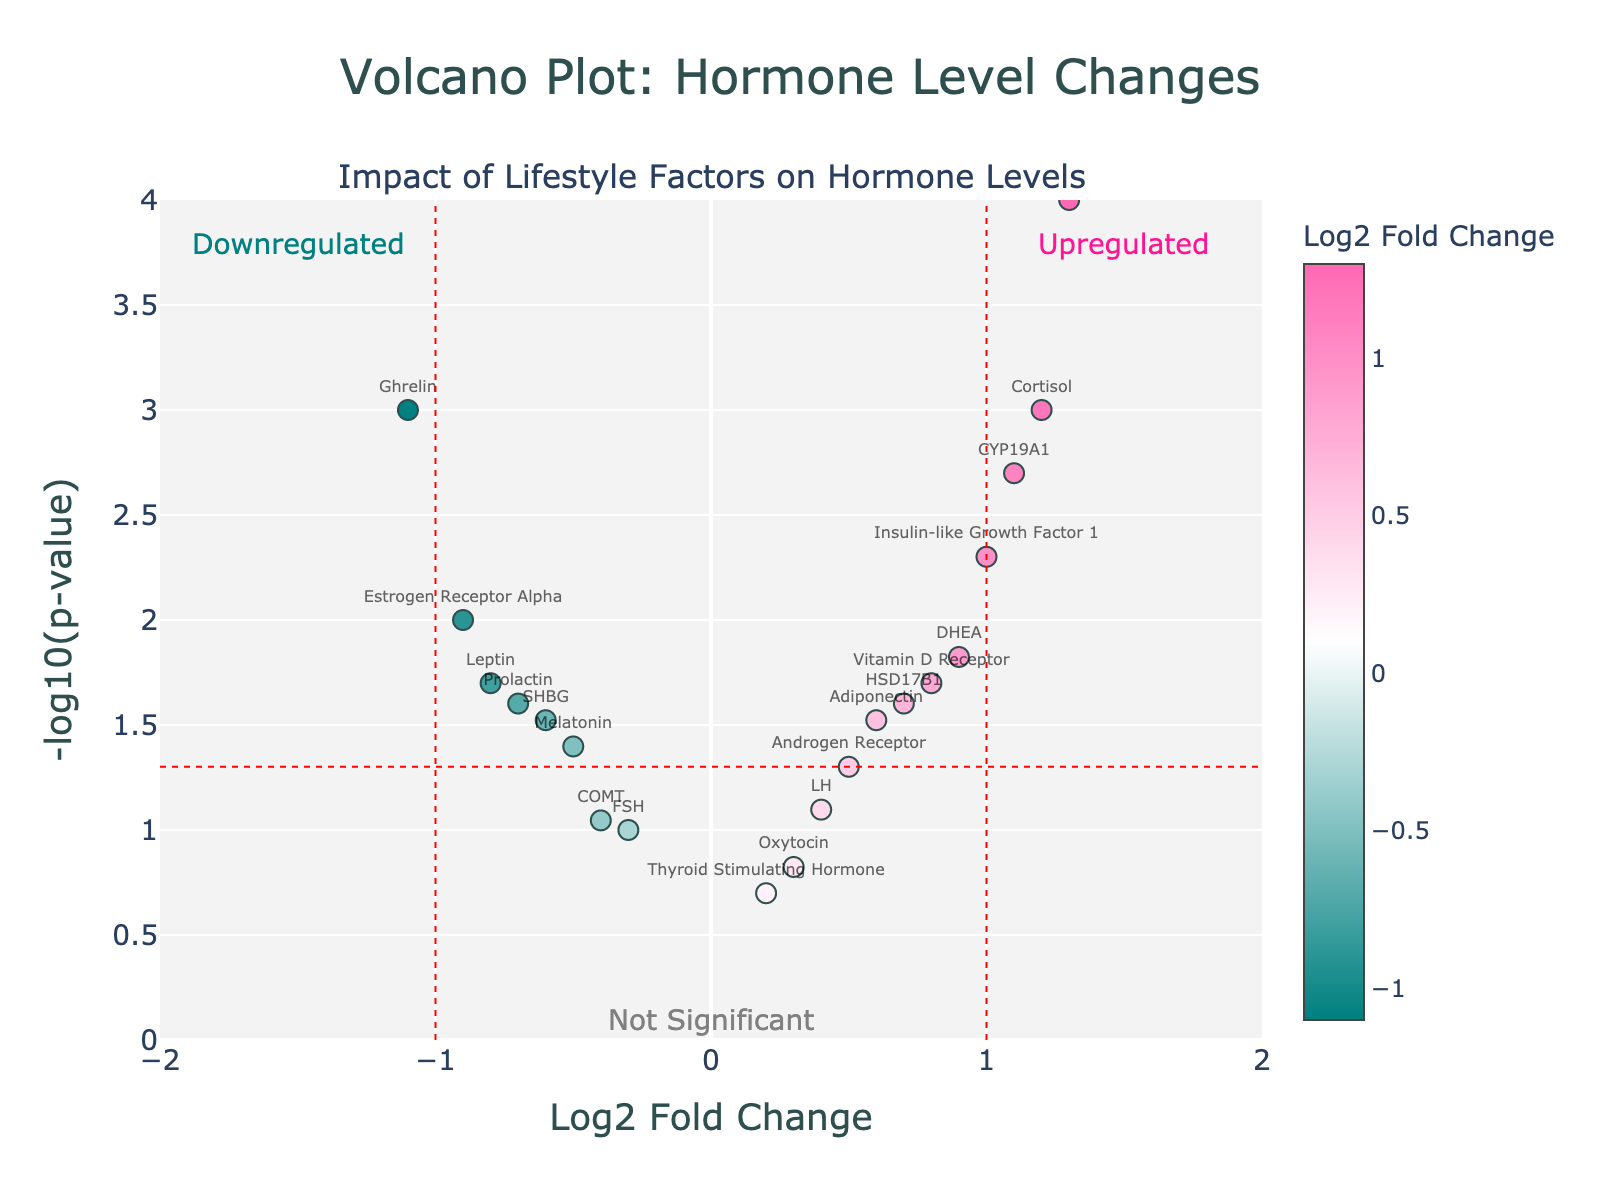What's the title of the plot? The title is prominently displayed at the top of the plot.
Answer: Volcano Plot: Hormone Level Changes Which hormone has the highest positive Log2 Fold Change? Look for the data point furthest to the right on the x-axis. Based on the data, Progesterone Receptor has the highest positive Log2 Fold Change.
Answer: Progesterone Receptor Which hormones fall within the "Downregulated" region? Examine the data points to the left of the Log2 Fold Change threshold line (x = -1) and identify their labels.
Answer: Leptin, Melatonin, Prolactin, Estrogen Receptor Alpha, Ghrelin, SHBG How many hormones have a Log2 Fold Change greater than 0.5? Count the number of data points with x-values greater than 0.5. These are Adiponectin, Insulin-like Growth Factor 1, Vitamin D Receptor, Progesterone Receptor, DHEA, Cortisol, and CYP19A1.
Answer: 7 What threshold P-Value is indicated by the horizontal red dashed line? The horizontal red dashed line is at -log10(0.05), which implies the p-value threshold is 0.05.
Answer: 0.05 Which hormone has the lowest P-Value? Find the data point with the highest y-axis value, as -log10(p-value) is plotted on the y-axis. Based on the data, the Progesterone Receptor has the lowest p-value.
Answer: Progesterone Receptor Compare the Log2 Fold Change values for Cortisol and Estrogen Receptor Alpha. Which one is higher? Look at the x-values for Cortisol (1.2) and Estrogen Receptor Alpha (-0.9). Cortisol has a higher value.
Answer: Cortisol Which hormone is closest to Log2 Fold Change of zero but has a significant P-Value (P < 0.05)? Identify the data point closest to the y-axis at x = 0 with a -log10(p-value) greater than the threshold line indicating significance. This would be Melatonin.
Answer: Melatonin Are there more hormones with increased levels (positive Log2 Fold Change) or decreased levels (negative Log2 Fold Change)? Count the data points on each side of the y-axis. There are more data points on the left (negative Log2 Fold Change).
Answer: Decreased levels Which hormones show significant changes (P < 0.05) and are labeled in the plot? Check the data points above the horizontal red dashed line and note their labels.
Answer: Leptin, Adiponectin, Cortisol, Melatonin, DHEA, Prolactin, Insulin-like Growth Factor 1, Ghrelin, Vitamin D Receptor, Progesterone Receptor, Estrogen Receptor Alpha, CYP19A1, SHBG, HSD17B1 